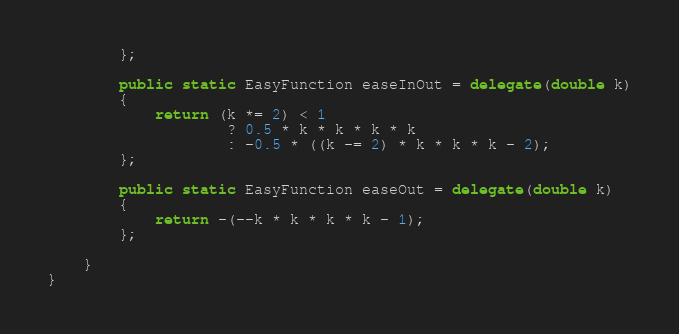Convert code to text. <code><loc_0><loc_0><loc_500><loc_500><_C#_>		};

		public static EasyFunction easeInOut = delegate(double k)
		{
			return (k *= 2) < 1
					? 0.5 * k * k * k * k
					: -0.5 * ((k -= 2) * k * k * k - 2);
		};

		public static EasyFunction easeOut = delegate(double k)
		{
			return -(--k * k * k * k - 1);
		};

	}
}</code> 